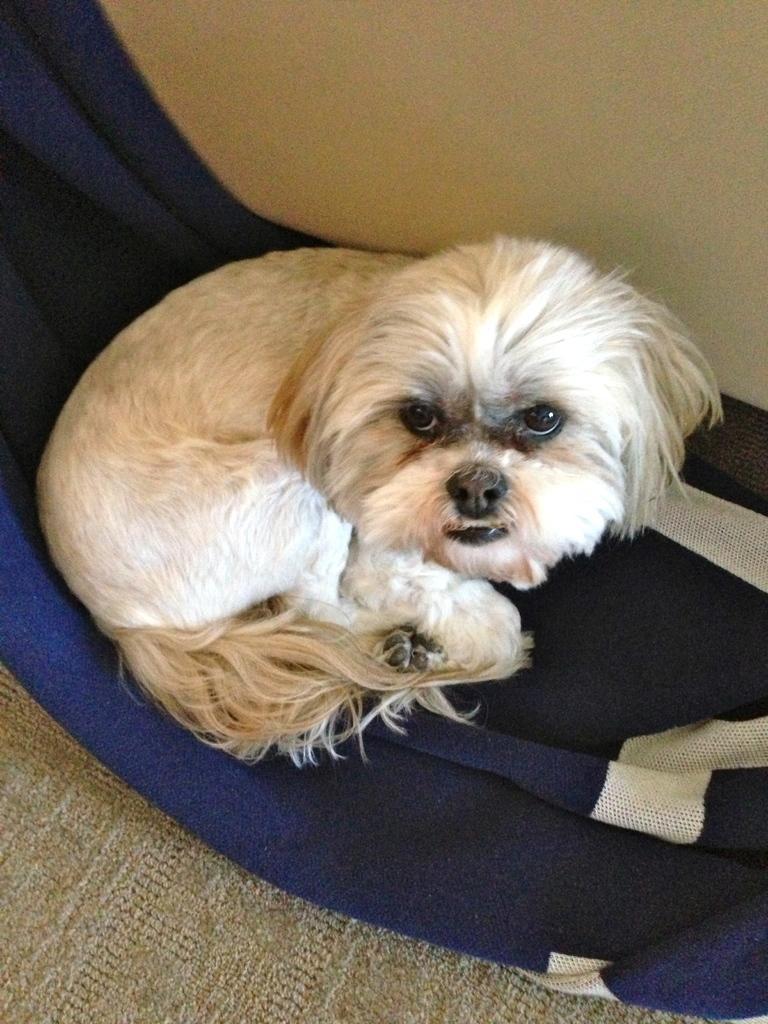Describe this image in one or two sentences. In this picture I can see a dog. This dog is in white color. We can observe blue color match on which this dog is sitting. In the background I can observe a wall. 